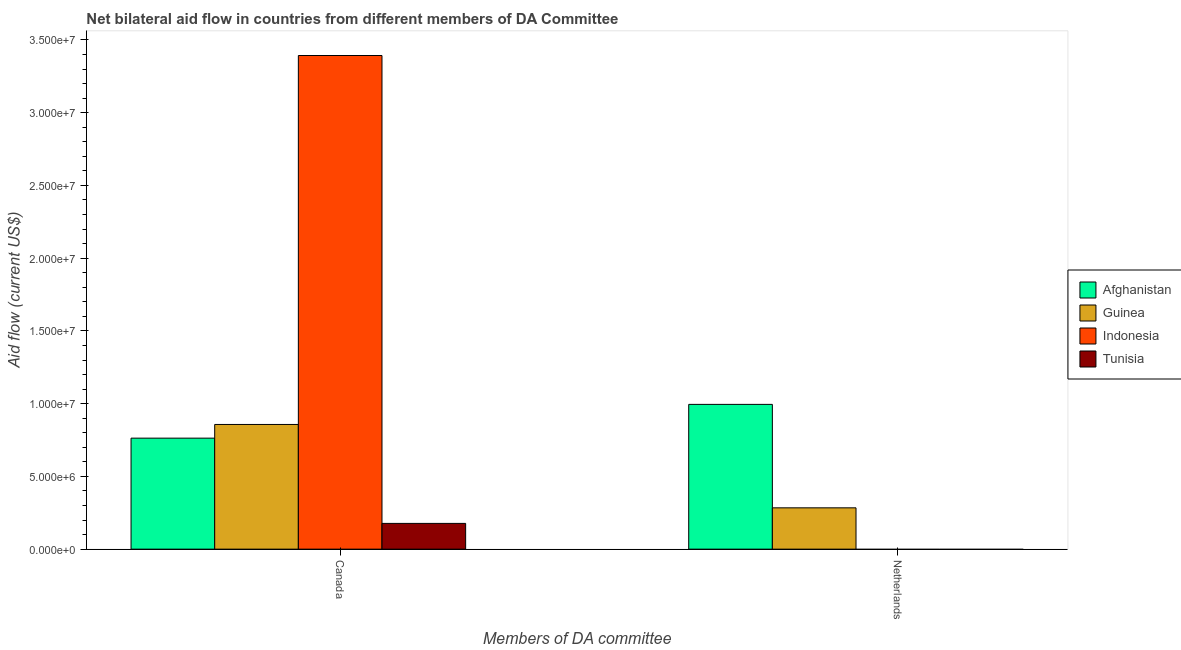How many different coloured bars are there?
Your answer should be compact. 4. How many groups of bars are there?
Offer a terse response. 2. Are the number of bars on each tick of the X-axis equal?
Provide a succinct answer. No. How many bars are there on the 1st tick from the left?
Keep it short and to the point. 4. How many bars are there on the 1st tick from the right?
Provide a succinct answer. 2. What is the label of the 1st group of bars from the left?
Keep it short and to the point. Canada. What is the amount of aid given by canada in Afghanistan?
Offer a terse response. 7.63e+06. Across all countries, what is the maximum amount of aid given by canada?
Keep it short and to the point. 3.39e+07. Across all countries, what is the minimum amount of aid given by canada?
Offer a terse response. 1.77e+06. In which country was the amount of aid given by netherlands maximum?
Make the answer very short. Afghanistan. What is the total amount of aid given by netherlands in the graph?
Offer a terse response. 1.28e+07. What is the difference between the amount of aid given by canada in Tunisia and that in Guinea?
Your response must be concise. -6.80e+06. What is the difference between the amount of aid given by canada in Indonesia and the amount of aid given by netherlands in Guinea?
Ensure brevity in your answer.  3.11e+07. What is the average amount of aid given by canada per country?
Ensure brevity in your answer.  1.30e+07. What is the difference between the amount of aid given by canada and amount of aid given by netherlands in Guinea?
Your response must be concise. 5.73e+06. In how many countries, is the amount of aid given by canada greater than 14000000 US$?
Make the answer very short. 1. What is the ratio of the amount of aid given by canada in Tunisia to that in Afghanistan?
Offer a very short reply. 0.23. Is the amount of aid given by canada in Tunisia less than that in Afghanistan?
Ensure brevity in your answer.  Yes. Are all the bars in the graph horizontal?
Your answer should be compact. No. How many countries are there in the graph?
Your answer should be very brief. 4. What is the difference between two consecutive major ticks on the Y-axis?
Ensure brevity in your answer.  5.00e+06. Are the values on the major ticks of Y-axis written in scientific E-notation?
Offer a very short reply. Yes. Does the graph contain any zero values?
Ensure brevity in your answer.  Yes. What is the title of the graph?
Offer a very short reply. Net bilateral aid flow in countries from different members of DA Committee. What is the label or title of the X-axis?
Ensure brevity in your answer.  Members of DA committee. What is the label or title of the Y-axis?
Make the answer very short. Aid flow (current US$). What is the Aid flow (current US$) in Afghanistan in Canada?
Make the answer very short. 7.63e+06. What is the Aid flow (current US$) in Guinea in Canada?
Keep it short and to the point. 8.57e+06. What is the Aid flow (current US$) in Indonesia in Canada?
Offer a terse response. 3.39e+07. What is the Aid flow (current US$) in Tunisia in Canada?
Offer a very short reply. 1.77e+06. What is the Aid flow (current US$) in Afghanistan in Netherlands?
Offer a terse response. 9.95e+06. What is the Aid flow (current US$) of Guinea in Netherlands?
Keep it short and to the point. 2.84e+06. What is the Aid flow (current US$) of Indonesia in Netherlands?
Make the answer very short. 0. Across all Members of DA committee, what is the maximum Aid flow (current US$) of Afghanistan?
Provide a succinct answer. 9.95e+06. Across all Members of DA committee, what is the maximum Aid flow (current US$) of Guinea?
Make the answer very short. 8.57e+06. Across all Members of DA committee, what is the maximum Aid flow (current US$) of Indonesia?
Your answer should be compact. 3.39e+07. Across all Members of DA committee, what is the maximum Aid flow (current US$) of Tunisia?
Make the answer very short. 1.77e+06. Across all Members of DA committee, what is the minimum Aid flow (current US$) of Afghanistan?
Offer a very short reply. 7.63e+06. Across all Members of DA committee, what is the minimum Aid flow (current US$) in Guinea?
Provide a short and direct response. 2.84e+06. Across all Members of DA committee, what is the minimum Aid flow (current US$) in Indonesia?
Provide a succinct answer. 0. Across all Members of DA committee, what is the minimum Aid flow (current US$) of Tunisia?
Keep it short and to the point. 0. What is the total Aid flow (current US$) in Afghanistan in the graph?
Ensure brevity in your answer.  1.76e+07. What is the total Aid flow (current US$) of Guinea in the graph?
Provide a short and direct response. 1.14e+07. What is the total Aid flow (current US$) in Indonesia in the graph?
Give a very brief answer. 3.39e+07. What is the total Aid flow (current US$) of Tunisia in the graph?
Make the answer very short. 1.77e+06. What is the difference between the Aid flow (current US$) of Afghanistan in Canada and that in Netherlands?
Give a very brief answer. -2.32e+06. What is the difference between the Aid flow (current US$) in Guinea in Canada and that in Netherlands?
Your answer should be very brief. 5.73e+06. What is the difference between the Aid flow (current US$) of Afghanistan in Canada and the Aid flow (current US$) of Guinea in Netherlands?
Give a very brief answer. 4.79e+06. What is the average Aid flow (current US$) of Afghanistan per Members of DA committee?
Your answer should be compact. 8.79e+06. What is the average Aid flow (current US$) in Guinea per Members of DA committee?
Your response must be concise. 5.70e+06. What is the average Aid flow (current US$) in Indonesia per Members of DA committee?
Provide a succinct answer. 1.70e+07. What is the average Aid flow (current US$) in Tunisia per Members of DA committee?
Offer a terse response. 8.85e+05. What is the difference between the Aid flow (current US$) of Afghanistan and Aid flow (current US$) of Guinea in Canada?
Keep it short and to the point. -9.40e+05. What is the difference between the Aid flow (current US$) in Afghanistan and Aid flow (current US$) in Indonesia in Canada?
Your response must be concise. -2.63e+07. What is the difference between the Aid flow (current US$) of Afghanistan and Aid flow (current US$) of Tunisia in Canada?
Your answer should be compact. 5.86e+06. What is the difference between the Aid flow (current US$) in Guinea and Aid flow (current US$) in Indonesia in Canada?
Provide a succinct answer. -2.54e+07. What is the difference between the Aid flow (current US$) of Guinea and Aid flow (current US$) of Tunisia in Canada?
Give a very brief answer. 6.80e+06. What is the difference between the Aid flow (current US$) in Indonesia and Aid flow (current US$) in Tunisia in Canada?
Your answer should be compact. 3.22e+07. What is the difference between the Aid flow (current US$) of Afghanistan and Aid flow (current US$) of Guinea in Netherlands?
Offer a terse response. 7.11e+06. What is the ratio of the Aid flow (current US$) in Afghanistan in Canada to that in Netherlands?
Offer a very short reply. 0.77. What is the ratio of the Aid flow (current US$) of Guinea in Canada to that in Netherlands?
Your answer should be very brief. 3.02. What is the difference between the highest and the second highest Aid flow (current US$) of Afghanistan?
Your answer should be very brief. 2.32e+06. What is the difference between the highest and the second highest Aid flow (current US$) of Guinea?
Make the answer very short. 5.73e+06. What is the difference between the highest and the lowest Aid flow (current US$) in Afghanistan?
Your answer should be compact. 2.32e+06. What is the difference between the highest and the lowest Aid flow (current US$) of Guinea?
Offer a very short reply. 5.73e+06. What is the difference between the highest and the lowest Aid flow (current US$) in Indonesia?
Offer a very short reply. 3.39e+07. What is the difference between the highest and the lowest Aid flow (current US$) of Tunisia?
Keep it short and to the point. 1.77e+06. 